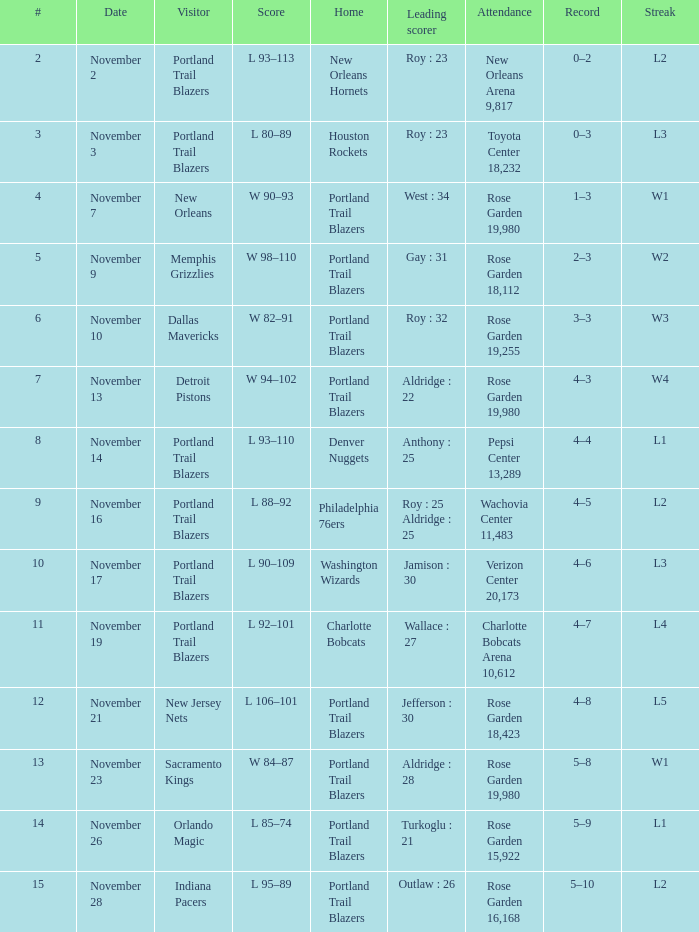 what's the home team where streak is l3 and leading scorer is roy : 23 Houston Rockets. 